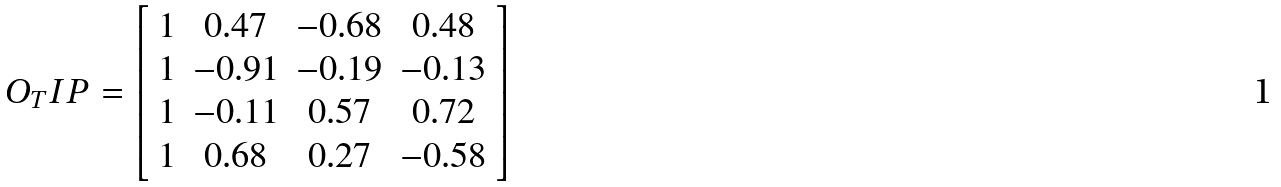<formula> <loc_0><loc_0><loc_500><loc_500>O _ { T } I P = \left [ \begin{array} { c c c c } 1 & 0 . 4 7 & - 0 . 6 8 & 0 . 4 8 \\ 1 & - 0 . 9 1 & - 0 . 1 9 & - 0 . 1 3 \\ 1 & - 0 . 1 1 & 0 . 5 7 & 0 . 7 2 \\ 1 & 0 . 6 8 & 0 . 2 7 & - 0 . 5 8 \end{array} \right ]</formula> 